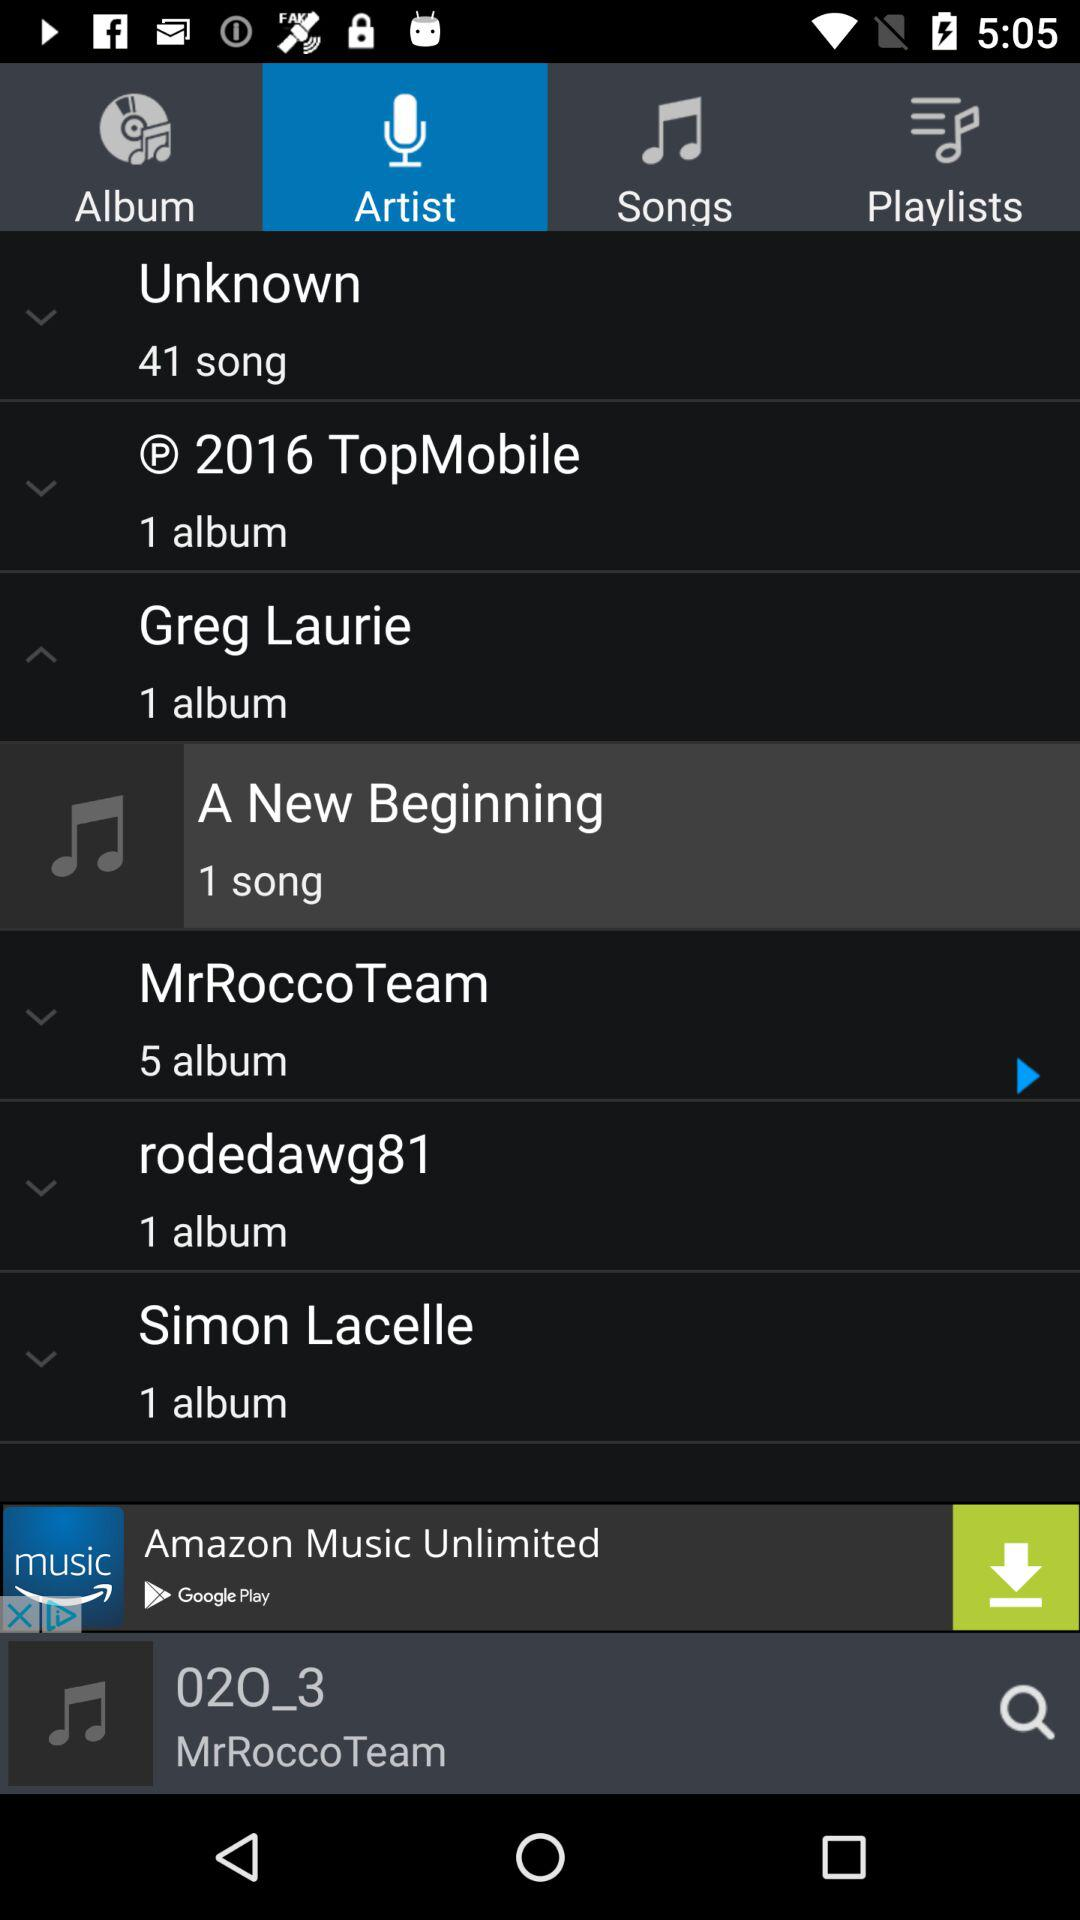How many albums do MrRocco Team and rodedawg81 have combined?
Answer the question using a single word or phrase. 6 